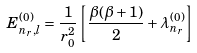Convert formula to latex. <formula><loc_0><loc_0><loc_500><loc_500>E _ { n _ { r } , l } ^ { ( 0 ) } = \frac { 1 } { r _ { 0 } ^ { 2 } } \left [ \frac { \beta ( \beta + 1 ) } { 2 } + \lambda _ { n _ { r } } ^ { ( 0 ) } \right ]</formula> 